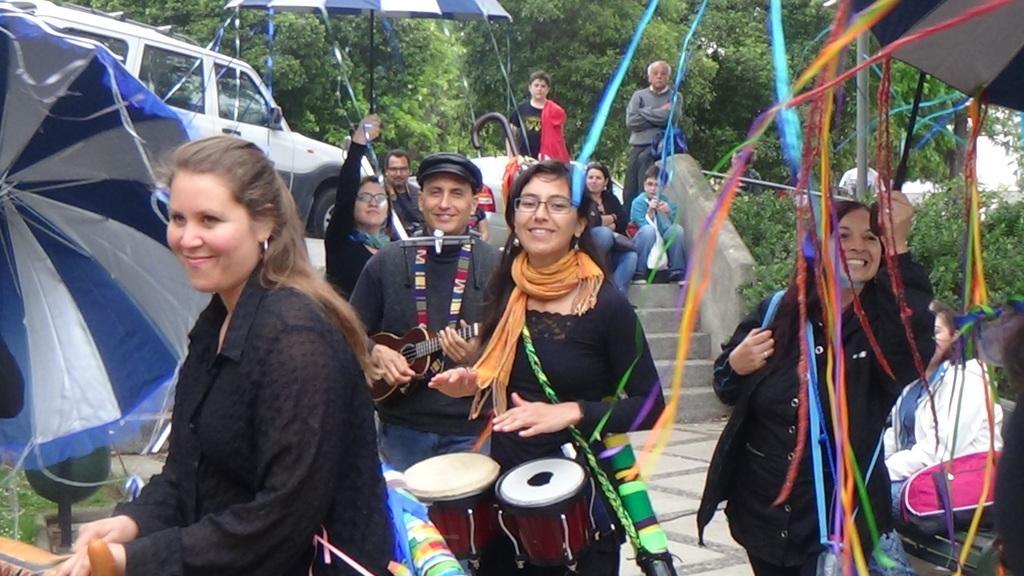Describe this image in one or two sentences. This picture describes about group of people few are standing and few are seated on the steps , in the middle of the image a man is playing guitar and a woman is playing drums, and also we can see an umbrella, a car and couple of trees. 